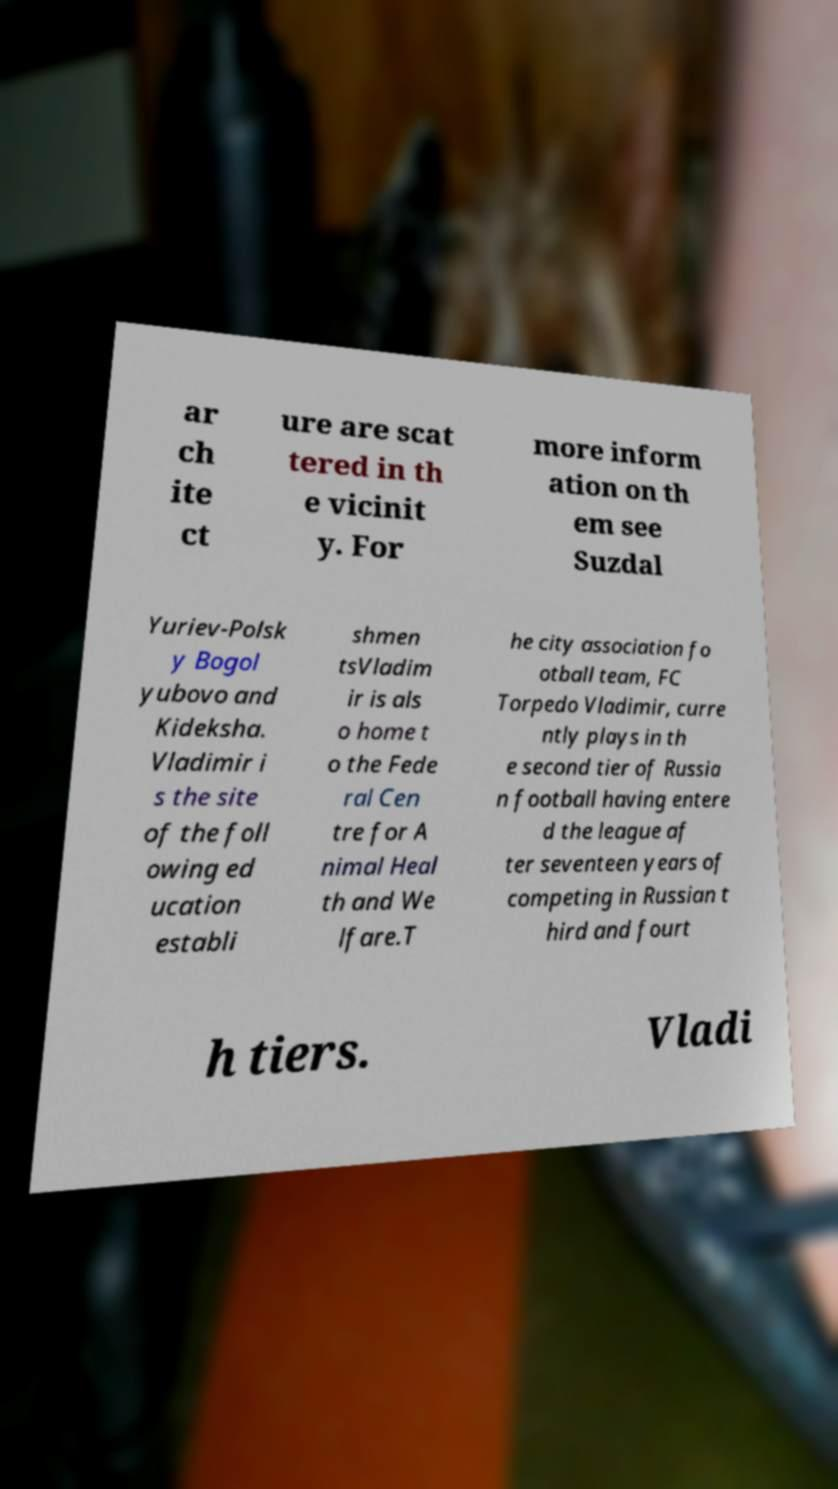For documentation purposes, I need the text within this image transcribed. Could you provide that? ar ch ite ct ure are scat tered in th e vicinit y. For more inform ation on th em see Suzdal Yuriev-Polsk y Bogol yubovo and Kideksha. Vladimir i s the site of the foll owing ed ucation establi shmen tsVladim ir is als o home t o the Fede ral Cen tre for A nimal Heal th and We lfare.T he city association fo otball team, FC Torpedo Vladimir, curre ntly plays in th e second tier of Russia n football having entere d the league af ter seventeen years of competing in Russian t hird and fourt h tiers. Vladi 